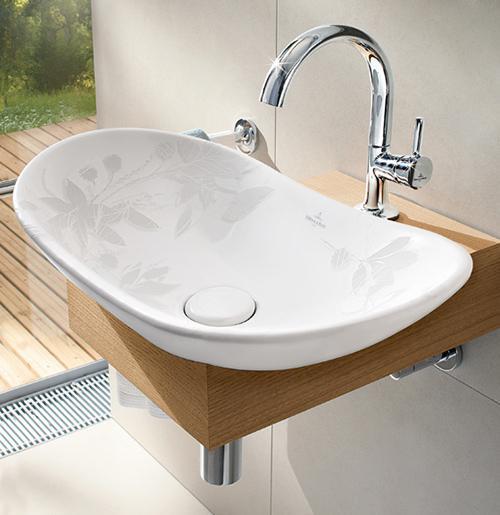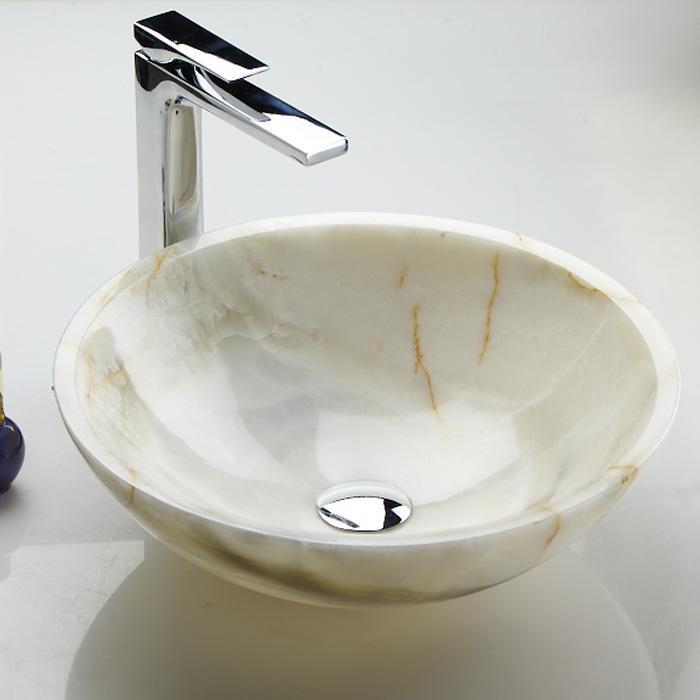The first image is the image on the left, the second image is the image on the right. Examine the images to the left and right. Is the description "Greenery can be seen past the sink on the left." accurate? Answer yes or no. Yes. 